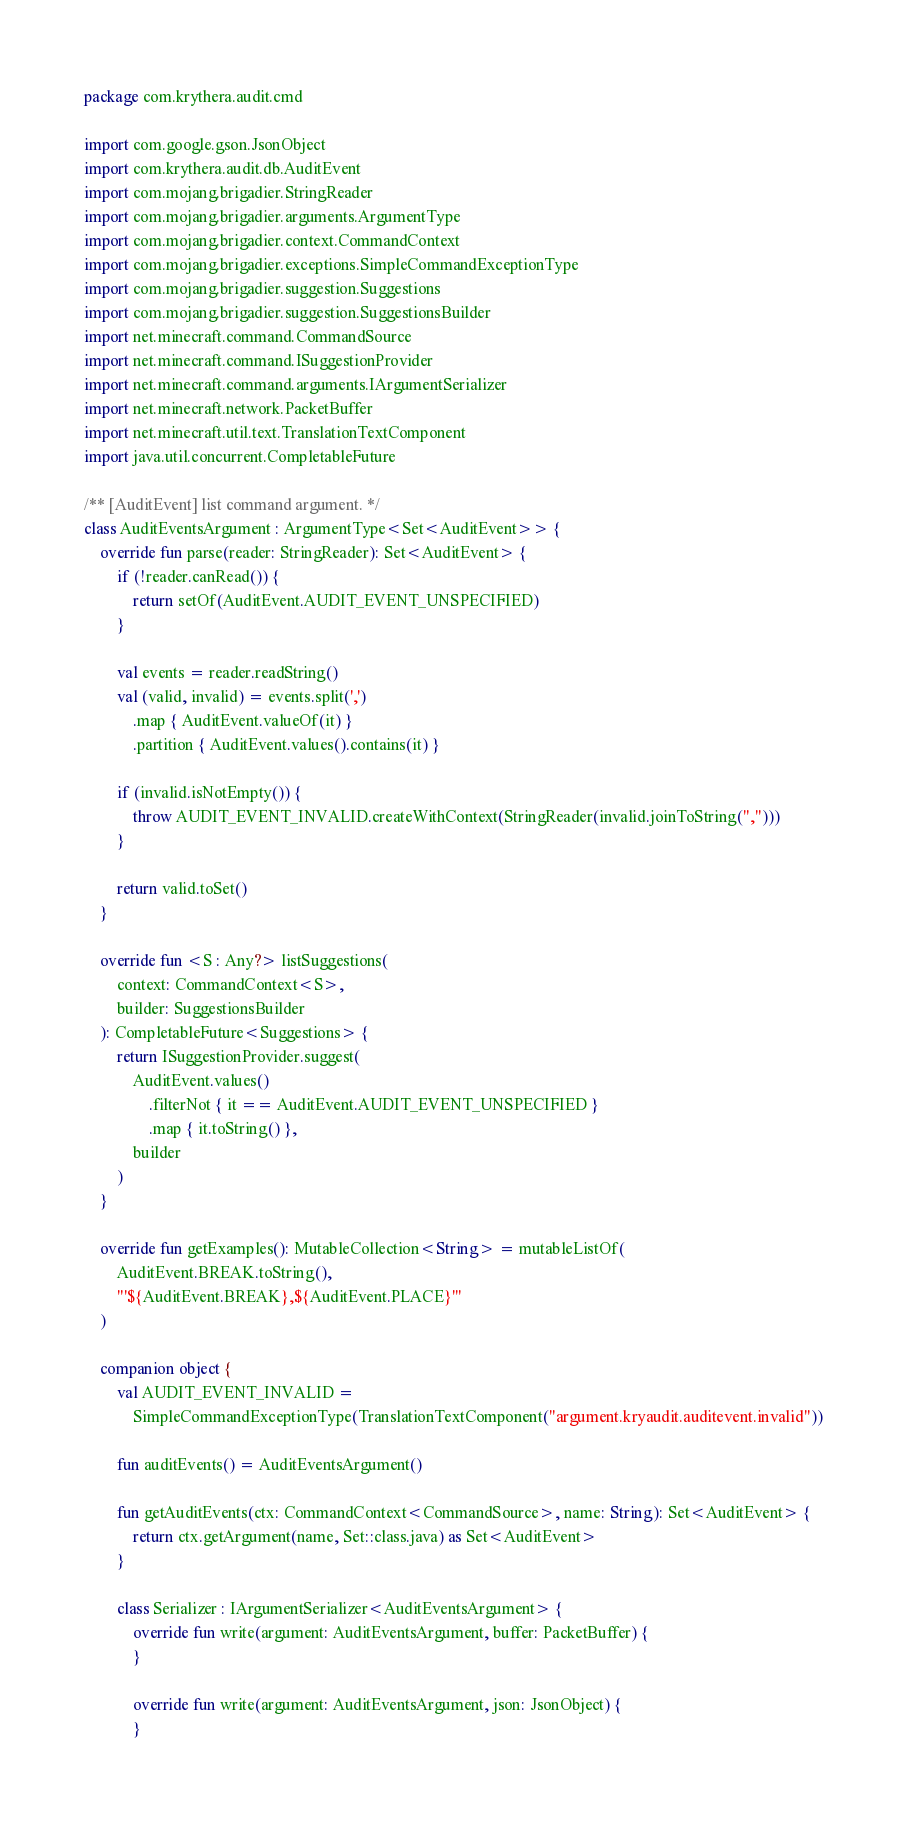Convert code to text. <code><loc_0><loc_0><loc_500><loc_500><_Kotlin_>package com.krythera.audit.cmd

import com.google.gson.JsonObject
import com.krythera.audit.db.AuditEvent
import com.mojang.brigadier.StringReader
import com.mojang.brigadier.arguments.ArgumentType
import com.mojang.brigadier.context.CommandContext
import com.mojang.brigadier.exceptions.SimpleCommandExceptionType
import com.mojang.brigadier.suggestion.Suggestions
import com.mojang.brigadier.suggestion.SuggestionsBuilder
import net.minecraft.command.CommandSource
import net.minecraft.command.ISuggestionProvider
import net.minecraft.command.arguments.IArgumentSerializer
import net.minecraft.network.PacketBuffer
import net.minecraft.util.text.TranslationTextComponent
import java.util.concurrent.CompletableFuture

/** [AuditEvent] list command argument. */
class AuditEventsArgument : ArgumentType<Set<AuditEvent>> {
    override fun parse(reader: StringReader): Set<AuditEvent> {
        if (!reader.canRead()) {
            return setOf(AuditEvent.AUDIT_EVENT_UNSPECIFIED)
        }

        val events = reader.readString()
        val (valid, invalid) = events.split(',')
            .map { AuditEvent.valueOf(it) }
            .partition { AuditEvent.values().contains(it) }

        if (invalid.isNotEmpty()) {
            throw AUDIT_EVENT_INVALID.createWithContext(StringReader(invalid.joinToString(",")))
        }

        return valid.toSet()
    }

    override fun <S : Any?> listSuggestions(
        context: CommandContext<S>,
        builder: SuggestionsBuilder
    ): CompletableFuture<Suggestions> {
        return ISuggestionProvider.suggest(
            AuditEvent.values()
                .filterNot { it == AuditEvent.AUDIT_EVENT_UNSPECIFIED }
                .map { it.toString() },
            builder
        )
    }

    override fun getExamples(): MutableCollection<String> = mutableListOf(
        AuditEvent.BREAK.toString(),
        "'${AuditEvent.BREAK},${AuditEvent.PLACE}'"
    )

    companion object {
        val AUDIT_EVENT_INVALID =
            SimpleCommandExceptionType(TranslationTextComponent("argument.kryaudit.auditevent.invalid"))

        fun auditEvents() = AuditEventsArgument()

        fun getAuditEvents(ctx: CommandContext<CommandSource>, name: String): Set<AuditEvent> {
            return ctx.getArgument(name, Set::class.java) as Set<AuditEvent>
        }

        class Serializer : IArgumentSerializer<AuditEventsArgument> {
            override fun write(argument: AuditEventsArgument, buffer: PacketBuffer) {
            }

            override fun write(argument: AuditEventsArgument, json: JsonObject) {
            }
</code> 